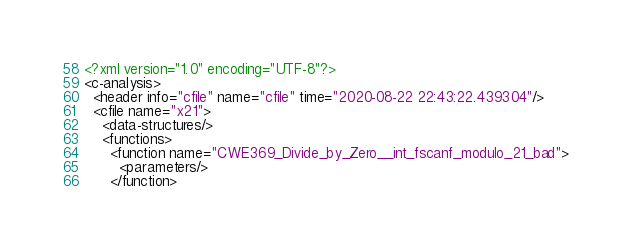<code> <loc_0><loc_0><loc_500><loc_500><_XML_><?xml version="1.0" encoding="UTF-8"?>
<c-analysis>
  <header info="cfile" name="cfile" time="2020-08-22 22:43:22.439304"/>
  <cfile name="x21">
    <data-structures/>
    <functions>
      <function name="CWE369_Divide_by_Zero__int_fscanf_modulo_21_bad">
        <parameters/>
      </function></code> 